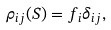<formula> <loc_0><loc_0><loc_500><loc_500>\rho _ { i j } ( S ) = f _ { i } \delta _ { i j } ,</formula> 